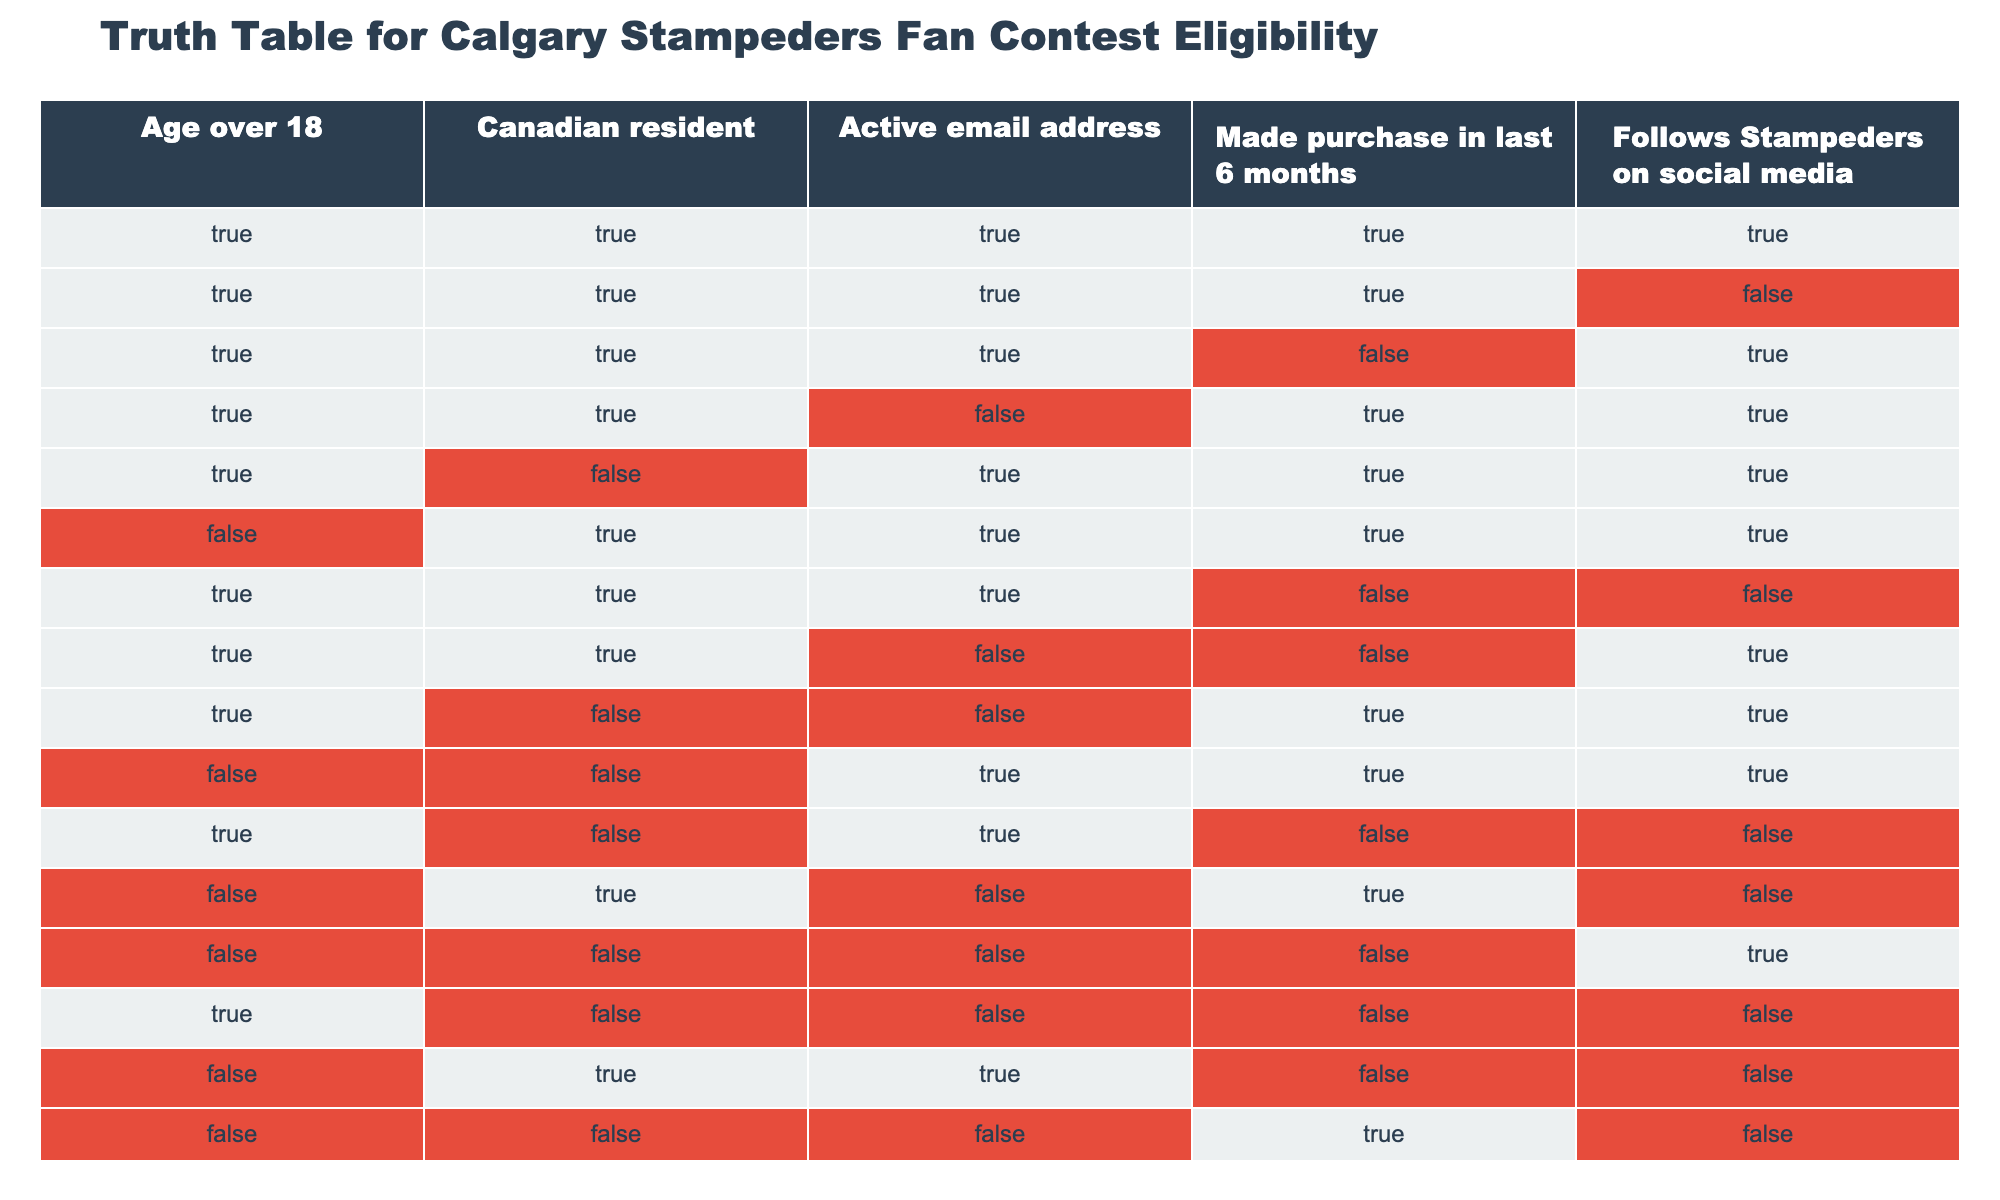What percentage of contestants have an active email address? There are 16 total entries. By counting the rows with "TRUE" under "Active email address," we find 10 instances. The percentage is calculated as (10/16)*100 = 62.5%
Answer: 62.5% How many contestants are Canadian residents and follow the Stampeders on social media? We count the rows where both "Canadian resident" and "Follows Stampeders on social media" are "TRUE." There are 5 such entries in the table.
Answer: 5 Is it true that all contestants over 18 made a purchase in the last 6 months? We check all rows where "Age over 18" is "TRUE" and filter for those with "Made purchase in last 6 months" equal to "FALSE." There are 3 rows with "TRUE" for age and "FALSE" for purchase. Therefore, it is not true that all contestants over 18 made a purchase.
Answer: No What is the count of contestants who are not Canadian residents and have made a purchase in the last 6 months? We look for rows where "Canadian resident" is "FALSE" and "Made purchase in last 6 months" is "TRUE." Upon inspection, we see that there are 2 contestants fitting this criteria.
Answer: 2 Among the contestants who are active email users, how many do not follow the Stampeders on social media? We identify rows where "Active email address" is "TRUE" and "Follows Stampeders on social media" is "FALSE." There are 2 contestants who meet this condition.
Answer: 2 What is the total number of contestants who meet all eligibility criteria? We take the intersection of all columns where each is "TRUE," which results in just 1 entry satisfying all criteria.
Answer: 1 How many contestants are both over 18 and have not followed the Stampeders on social media? We find entries where "Age over 18" is "TRUE" and "Follows Stampeders on social media" is "FALSE." There are 3 such entries in the table.
Answer: 3 Is it the case that none of the contestants under 18 follow the Stampeders on social media? All contestants are explicitly categorized by age, and the table shows that among the rows where age is "FALSE," there are still entries that follow on social media. Therefore, it is false that none of the under 18 contestants follow the Stampeders.
Answer: No 